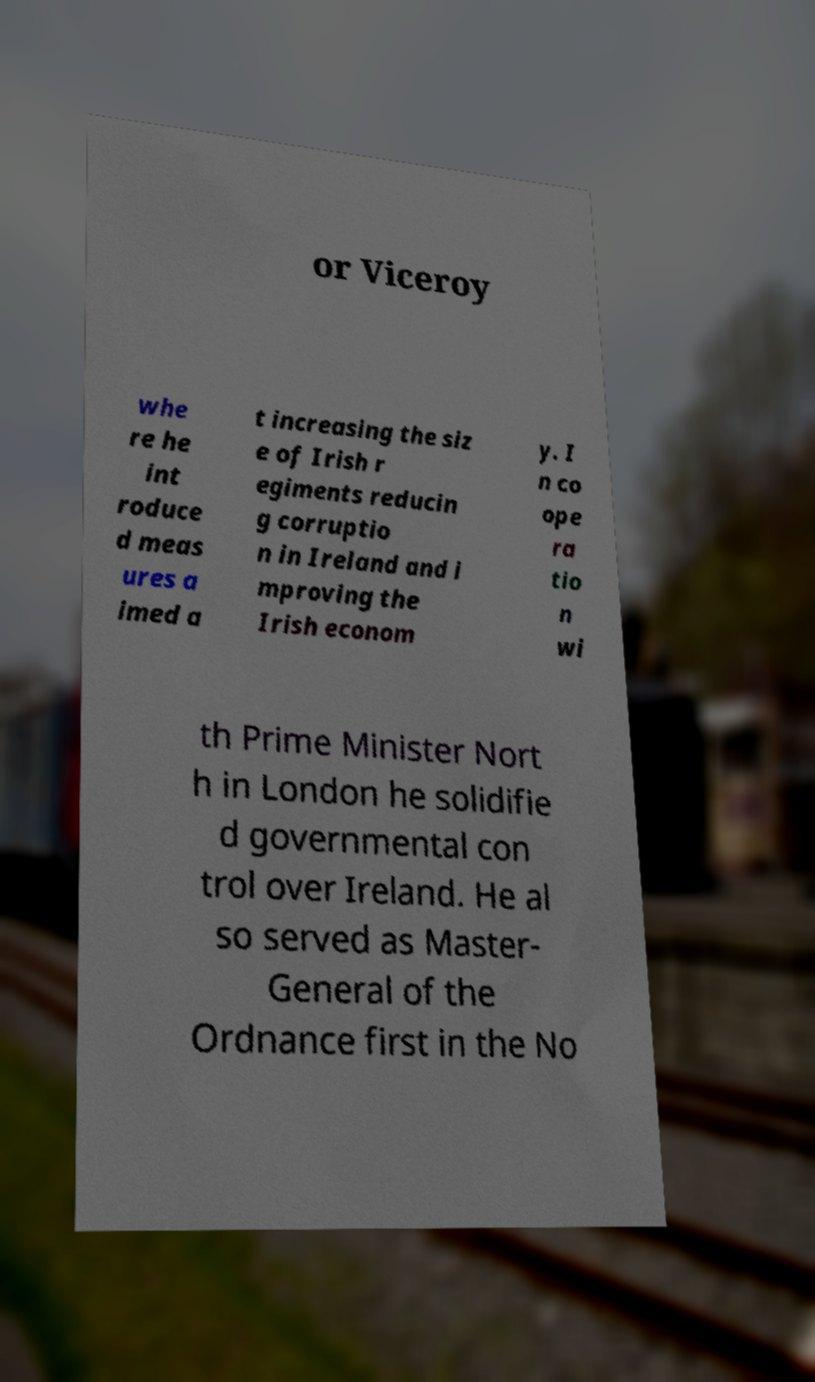Please read and relay the text visible in this image. What does it say? or Viceroy whe re he int roduce d meas ures a imed a t increasing the siz e of Irish r egiments reducin g corruptio n in Ireland and i mproving the Irish econom y. I n co ope ra tio n wi th Prime Minister Nort h in London he solidifie d governmental con trol over Ireland. He al so served as Master- General of the Ordnance first in the No 